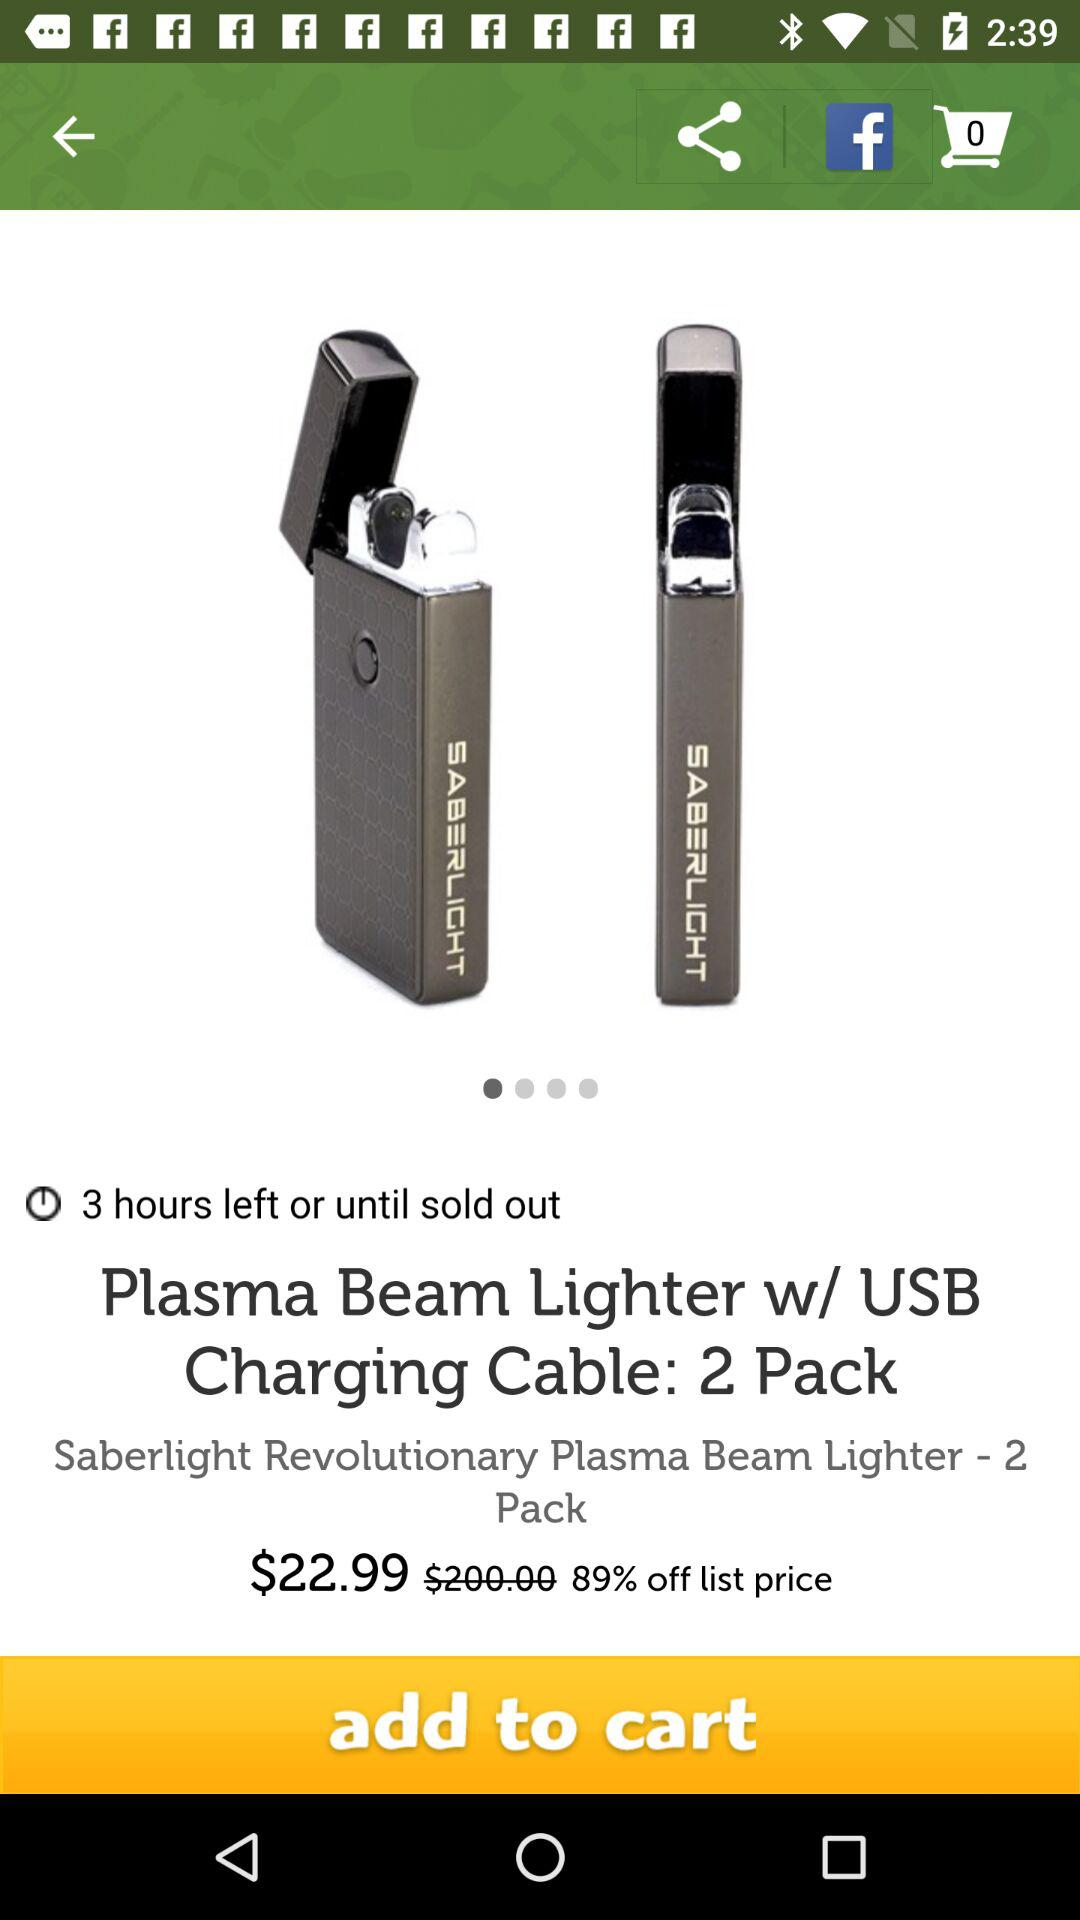What is the price of "Plasma Beam Lighter w/ USB Charging Cable: 2 Pack" after discount? The price after the discount is $22.99. 